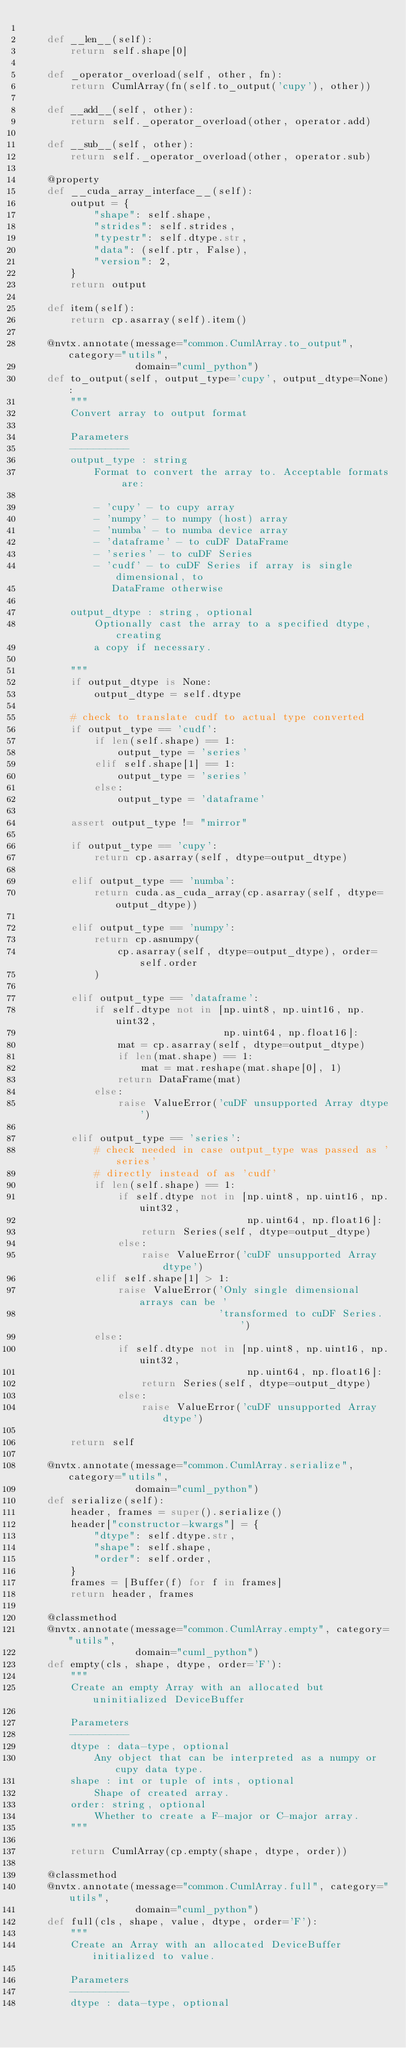Convert code to text. <code><loc_0><loc_0><loc_500><loc_500><_Python_>
    def __len__(self):
        return self.shape[0]

    def _operator_overload(self, other, fn):
        return CumlArray(fn(self.to_output('cupy'), other))

    def __add__(self, other):
        return self._operator_overload(other, operator.add)

    def __sub__(self, other):
        return self._operator_overload(other, operator.sub)

    @property
    def __cuda_array_interface__(self):
        output = {
            "shape": self.shape,
            "strides": self.strides,
            "typestr": self.dtype.str,
            "data": (self.ptr, False),
            "version": 2,
        }
        return output

    def item(self):
        return cp.asarray(self).item()

    @nvtx.annotate(message="common.CumlArray.to_output", category="utils",
                   domain="cuml_python")
    def to_output(self, output_type='cupy', output_dtype=None):
        """
        Convert array to output format

        Parameters
        ----------
        output_type : string
            Format to convert the array to. Acceptable formats are:

            - 'cupy' - to cupy array
            - 'numpy' - to numpy (host) array
            - 'numba' - to numba device array
            - 'dataframe' - to cuDF DataFrame
            - 'series' - to cuDF Series
            - 'cudf' - to cuDF Series if array is single dimensional, to
               DataFrame otherwise

        output_dtype : string, optional
            Optionally cast the array to a specified dtype, creating
            a copy if necessary.

        """
        if output_dtype is None:
            output_dtype = self.dtype

        # check to translate cudf to actual type converted
        if output_type == 'cudf':
            if len(self.shape) == 1:
                output_type = 'series'
            elif self.shape[1] == 1:
                output_type = 'series'
            else:
                output_type = 'dataframe'

        assert output_type != "mirror"

        if output_type == 'cupy':
            return cp.asarray(self, dtype=output_dtype)

        elif output_type == 'numba':
            return cuda.as_cuda_array(cp.asarray(self, dtype=output_dtype))

        elif output_type == 'numpy':
            return cp.asnumpy(
                cp.asarray(self, dtype=output_dtype), order=self.order
            )

        elif output_type == 'dataframe':
            if self.dtype not in [np.uint8, np.uint16, np.uint32,
                                  np.uint64, np.float16]:
                mat = cp.asarray(self, dtype=output_dtype)
                if len(mat.shape) == 1:
                    mat = mat.reshape(mat.shape[0], 1)
                return DataFrame(mat)
            else:
                raise ValueError('cuDF unsupported Array dtype')

        elif output_type == 'series':
            # check needed in case output_type was passed as 'series'
            # directly instead of as 'cudf'
            if len(self.shape) == 1:
                if self.dtype not in [np.uint8, np.uint16, np.uint32,
                                      np.uint64, np.float16]:
                    return Series(self, dtype=output_dtype)
                else:
                    raise ValueError('cuDF unsupported Array dtype')
            elif self.shape[1] > 1:
                raise ValueError('Only single dimensional arrays can be '
                                 'transformed to cuDF Series. ')
            else:
                if self.dtype not in [np.uint8, np.uint16, np.uint32,
                                      np.uint64, np.float16]:
                    return Series(self, dtype=output_dtype)
                else:
                    raise ValueError('cuDF unsupported Array dtype')

        return self

    @nvtx.annotate(message="common.CumlArray.serialize", category="utils",
                   domain="cuml_python")
    def serialize(self):
        header, frames = super().serialize()
        header["constructor-kwargs"] = {
            "dtype": self.dtype.str,
            "shape": self.shape,
            "order": self.order,
        }
        frames = [Buffer(f) for f in frames]
        return header, frames

    @classmethod
    @nvtx.annotate(message="common.CumlArray.empty", category="utils",
                   domain="cuml_python")
    def empty(cls, shape, dtype, order='F'):
        """
        Create an empty Array with an allocated but uninitialized DeviceBuffer

        Parameters
        ----------
        dtype : data-type, optional
            Any object that can be interpreted as a numpy or cupy data type.
        shape : int or tuple of ints, optional
            Shape of created array.
        order: string, optional
            Whether to create a F-major or C-major array.
        """

        return CumlArray(cp.empty(shape, dtype, order))

    @classmethod
    @nvtx.annotate(message="common.CumlArray.full", category="utils",
                   domain="cuml_python")
    def full(cls, shape, value, dtype, order='F'):
        """
        Create an Array with an allocated DeviceBuffer initialized to value.

        Parameters
        ----------
        dtype : data-type, optional</code> 